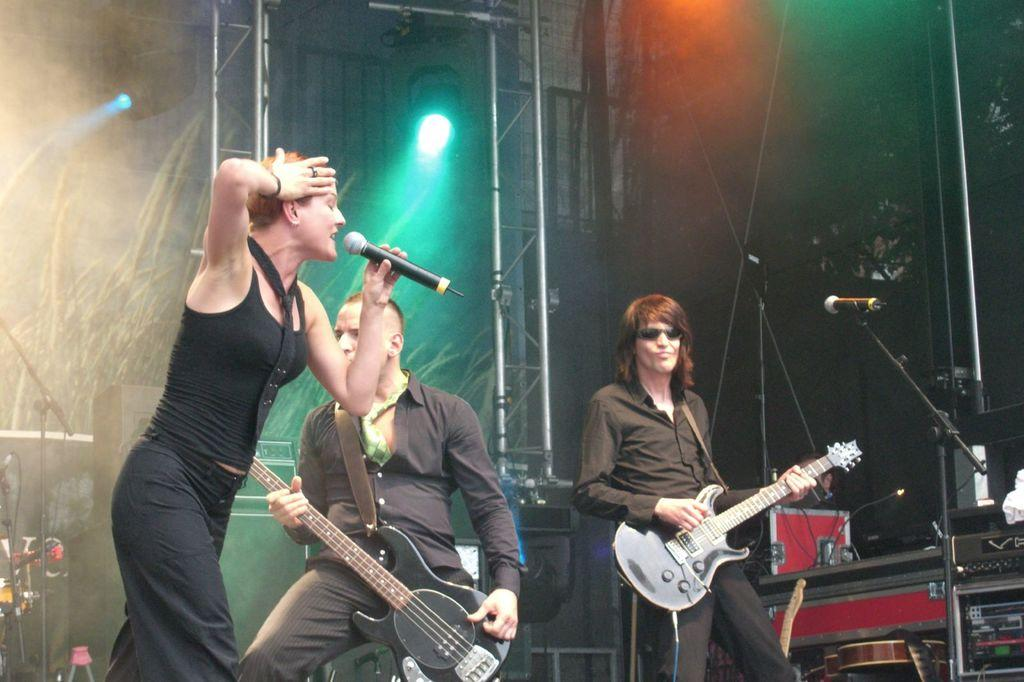What is the woman in the image holding? The woman is holding a microphone. What are the two men in the image holding? The two men are holding guitars. Is there any equipment for amplifying sound in the image? Yes, there is a microphone with a holder in the image. What type of light can be seen in the image? There is a focusing light in the image. What type of toothbrush is the woman using to play the guitar in the image? There is no toothbrush present in the image, and the woman is not playing the guitar; she is holding a microphone. 